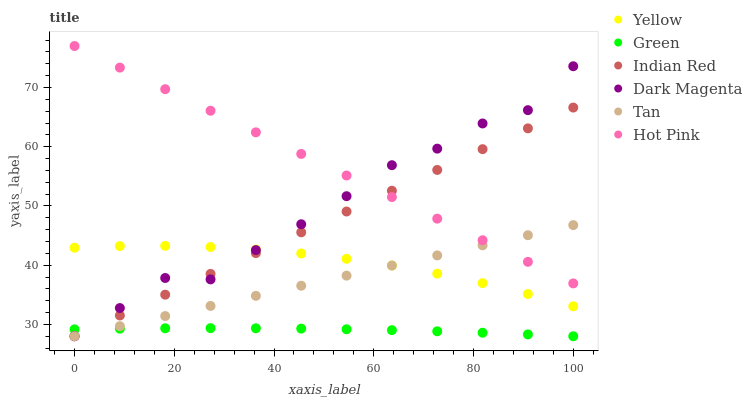Does Green have the minimum area under the curve?
Answer yes or no. Yes. Does Hot Pink have the maximum area under the curve?
Answer yes or no. Yes. Does Yellow have the minimum area under the curve?
Answer yes or no. No. Does Yellow have the maximum area under the curve?
Answer yes or no. No. Is Tan the smoothest?
Answer yes or no. Yes. Is Dark Magenta the roughest?
Answer yes or no. Yes. Is Hot Pink the smoothest?
Answer yes or no. No. Is Hot Pink the roughest?
Answer yes or no. No. Does Dark Magenta have the lowest value?
Answer yes or no. Yes. Does Yellow have the lowest value?
Answer yes or no. No. Does Hot Pink have the highest value?
Answer yes or no. Yes. Does Yellow have the highest value?
Answer yes or no. No. Is Yellow less than Hot Pink?
Answer yes or no. Yes. Is Hot Pink greater than Yellow?
Answer yes or no. Yes. Does Hot Pink intersect Tan?
Answer yes or no. Yes. Is Hot Pink less than Tan?
Answer yes or no. No. Is Hot Pink greater than Tan?
Answer yes or no. No. Does Yellow intersect Hot Pink?
Answer yes or no. No. 